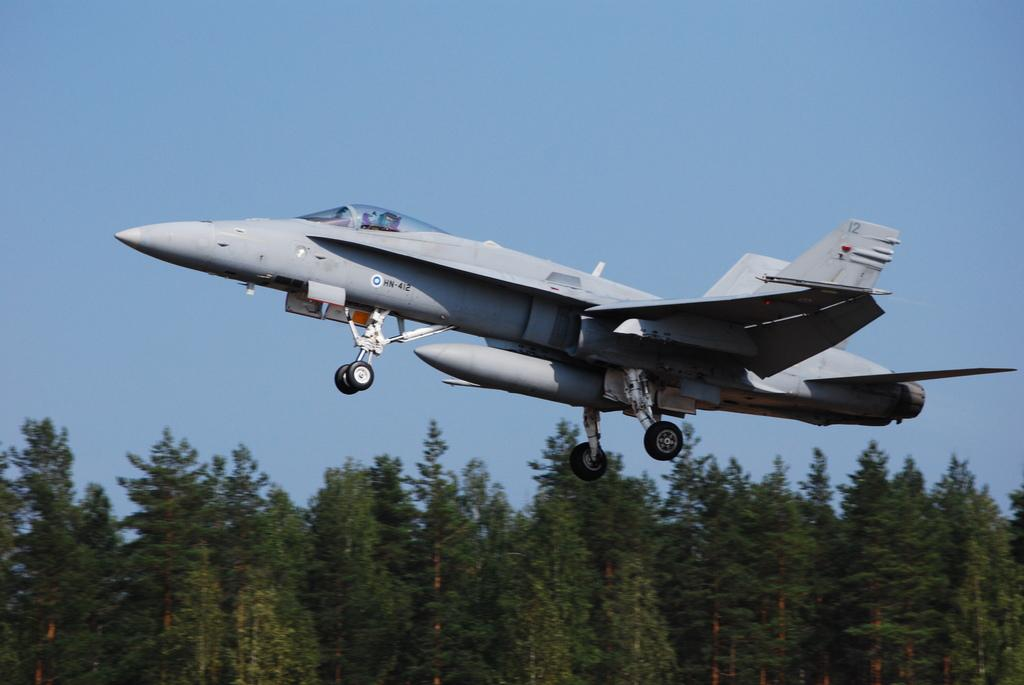What is the main subject of the image? The main subject of the image is an airplane. What other objects or elements can be seen in the image? There are trees in the image. What can be seen in the background of the image? The sky is visible in the background of the image. How many fingers can be seen holding the airplane in the image? There are no fingers or hands holding the airplane in the image. 